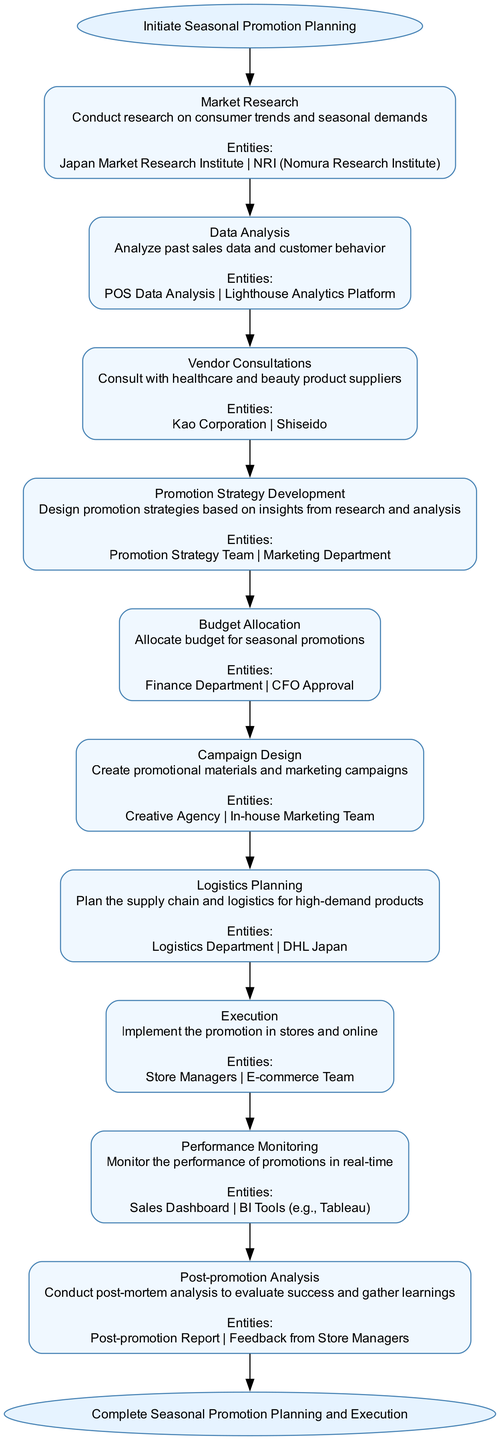What is the first step in the Seasonal Promotion Planning Flow? The first step is indicated as "Market Research" in the diagram, which follows the "Initiate Seasonal Promotion Planning" start node.
Answer: Market Research How many steps are there in total in the Seasonal Promotion Planning Flow? By counting the nodes representing steps in the flow after the start, we find there are ten steps total before reaching the end node.
Answer: 10 What type of analysis is conducted after the execution step? The final step in the flow indicates that there is a "Post-promotion Analysis" conducted after the promotions are executed to evaluate their success.
Answer: Post-promotion Analysis Which department is responsible for budget allocation? The Budgets are allocated by the "Finance Department" as shown in the corresponding step node before moving into the Campaign Design phase.
Answer: Finance Department If a promotional strategy is developed, which department collaborates with the Promotion Strategy Team? The "Marketing Department" collaborates with the Promotion Strategy Team, as indicated in the corresponding step that follows Vendor Consultations.
Answer: Marketing Department Which step comes immediately after "Logistics Planning"? The step that directly follows "Logistics Planning" in the flowchart is "Execution," which involves implementing the promotions.
Answer: Execution What is the last node in the Seasonal Promotion Planning Flow? The diagram concludes with the "Complete Seasonal Promotion Planning and Execution" end node, indicating the end of the process.
Answer: Complete Seasonal Promotion Planning and Execution How are the insights gathered for developing the promotion strategy obtained? Insights for developing the promotion strategy come from previous steps, specifically from "Market Research" and "Data Analysis," which provide vital consumer trends and sales data.
Answer: Market Research and Data Analysis 